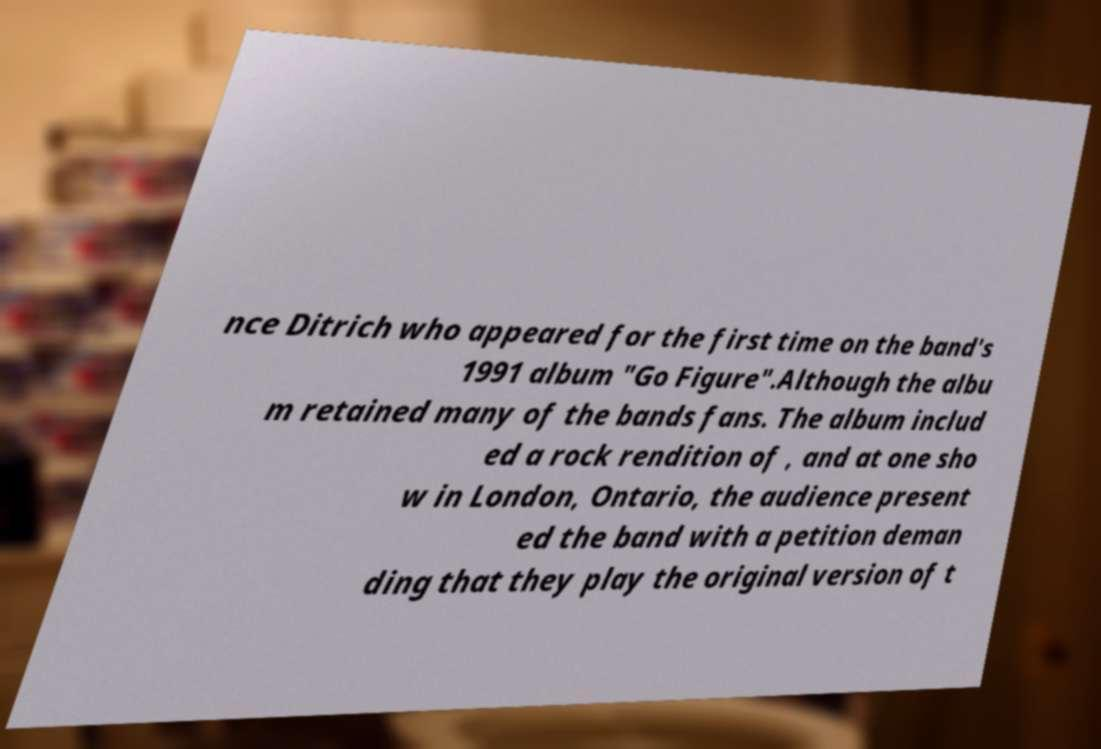Can you read and provide the text displayed in the image?This photo seems to have some interesting text. Can you extract and type it out for me? nce Ditrich who appeared for the first time on the band's 1991 album "Go Figure".Although the albu m retained many of the bands fans. The album includ ed a rock rendition of , and at one sho w in London, Ontario, the audience present ed the band with a petition deman ding that they play the original version of t 